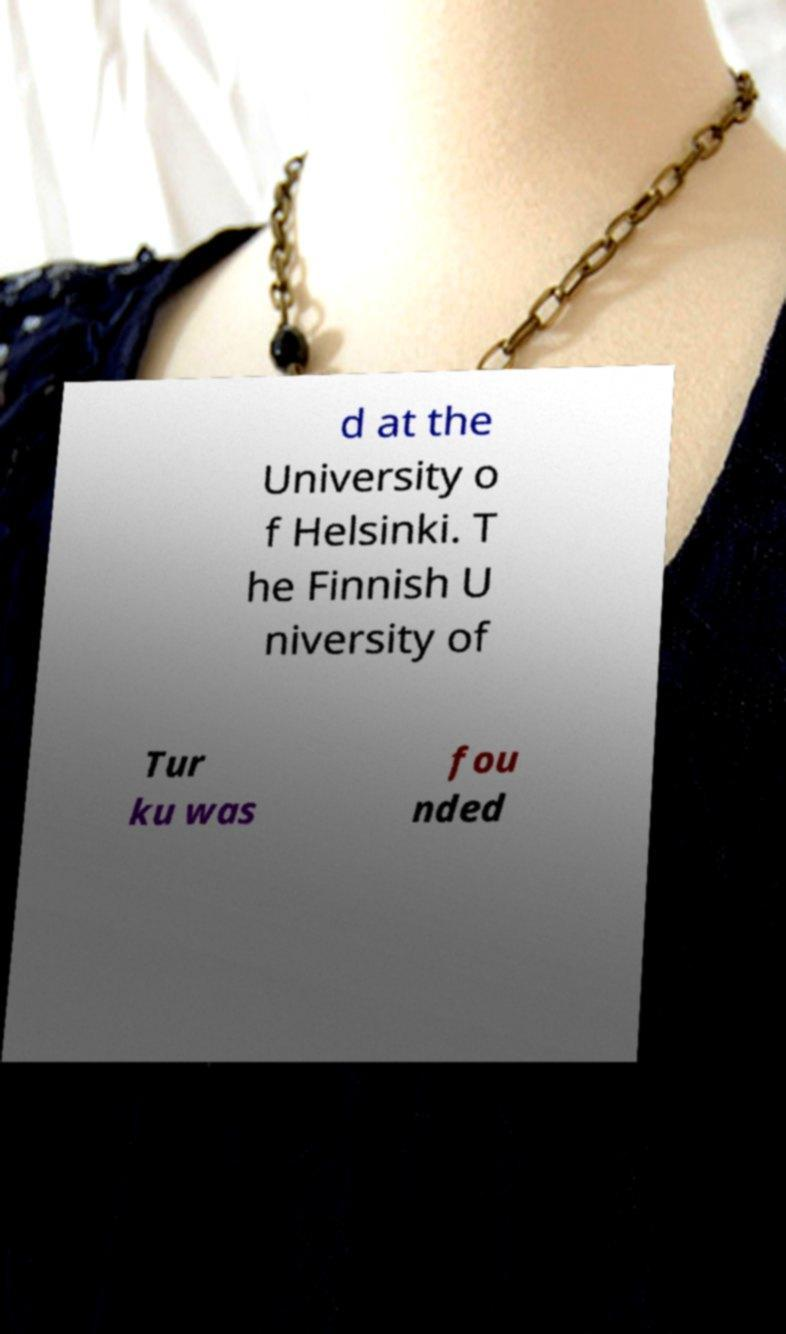Can you accurately transcribe the text from the provided image for me? d at the University o f Helsinki. T he Finnish U niversity of Tur ku was fou nded 